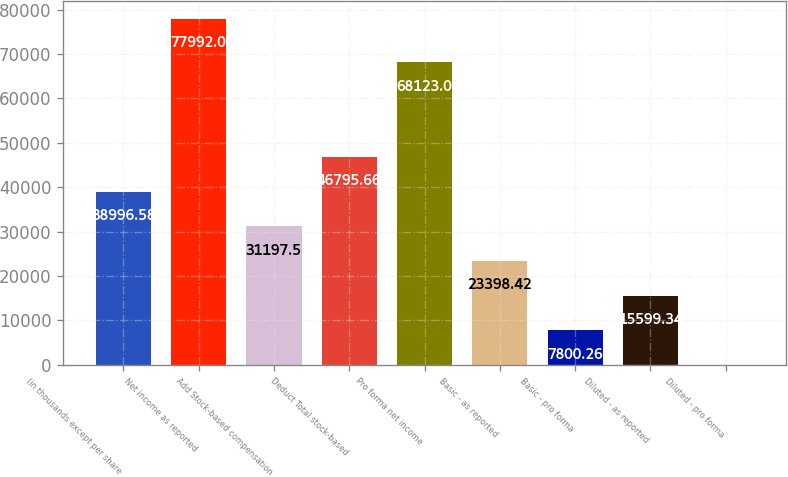Convert chart to OTSL. <chart><loc_0><loc_0><loc_500><loc_500><bar_chart><fcel>(in thousands except per share<fcel>Net income as reported<fcel>Add Stock-based compensation<fcel>Deduct Total stock-based<fcel>Pro forma net income<fcel>Basic - as reported<fcel>Basic - pro forma<fcel>Diluted - as reported<fcel>Diluted - pro forma<nl><fcel>38996.6<fcel>77992<fcel>31197.5<fcel>46795.7<fcel>68123<fcel>23398.4<fcel>7800.26<fcel>15599.3<fcel>1.18<nl></chart> 